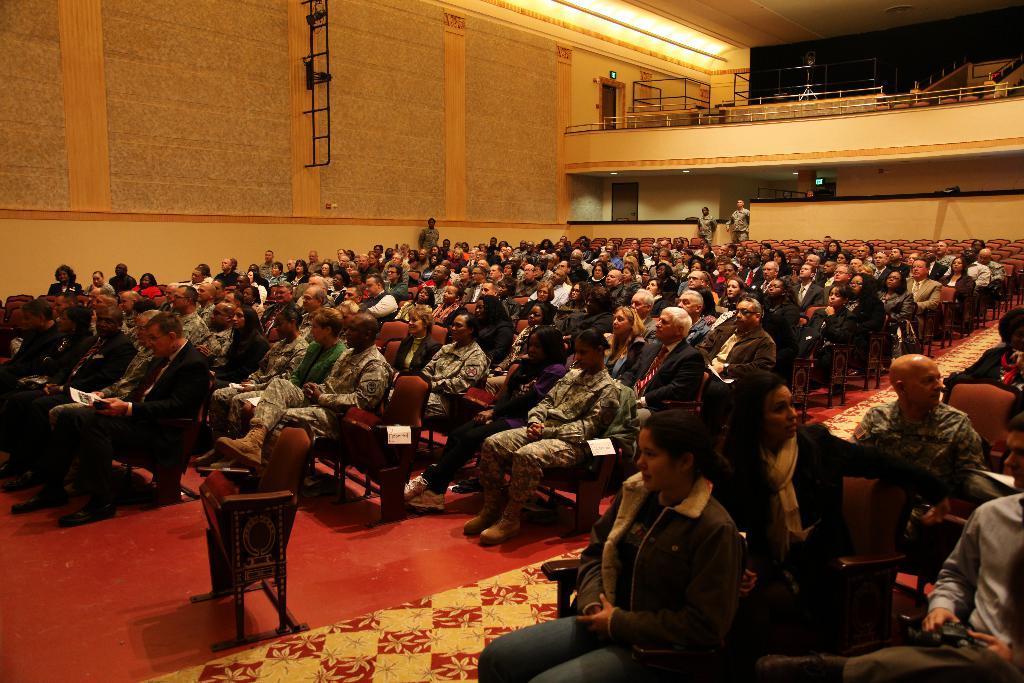How would you summarize this image in a sentence or two? In this picture we can see a group of people, some people are sitting on chairs, some people are standing and in the background we can see a wall, roof, rods and some objects. 